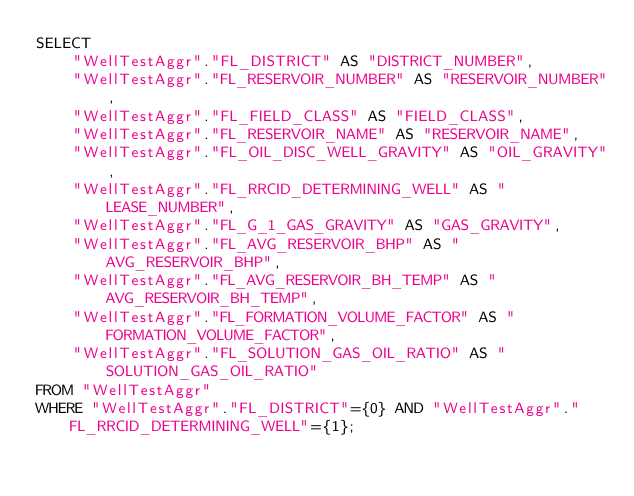Convert code to text. <code><loc_0><loc_0><loc_500><loc_500><_SQL_>SELECT
    "WellTestAggr"."FL_DISTRICT" AS "DISTRICT_NUMBER",
    "WellTestAggr"."FL_RESERVOIR_NUMBER" AS "RESERVOIR_NUMBER",
    "WellTestAggr"."FL_FIELD_CLASS" AS "FIELD_CLASS",
    "WellTestAggr"."FL_RESERVOIR_NAME" AS "RESERVOIR_NAME",
    "WellTestAggr"."FL_OIL_DISC_WELL_GRAVITY" AS "OIL_GRAVITY",
    "WellTestAggr"."FL_RRCID_DETERMINING_WELL" AS "LEASE_NUMBER",
    "WellTestAggr"."FL_G_1_GAS_GRAVITY" AS "GAS_GRAVITY",
    "WellTestAggr"."FL_AVG_RESERVOIR_BHP" AS "AVG_RESERVOIR_BHP",
    "WellTestAggr"."FL_AVG_RESERVOIR_BH_TEMP" AS "AVG_RESERVOIR_BH_TEMP",
    "WellTestAggr"."FL_FORMATION_VOLUME_FACTOR" AS "FORMATION_VOLUME_FACTOR",
    "WellTestAggr"."FL_SOLUTION_GAS_OIL_RATIO" AS "SOLUTION_GAS_OIL_RATIO"
FROM "WellTestAggr"
WHERE "WellTestAggr"."FL_DISTRICT"={0} AND "WellTestAggr"."FL_RRCID_DETERMINING_WELL"={1};</code> 